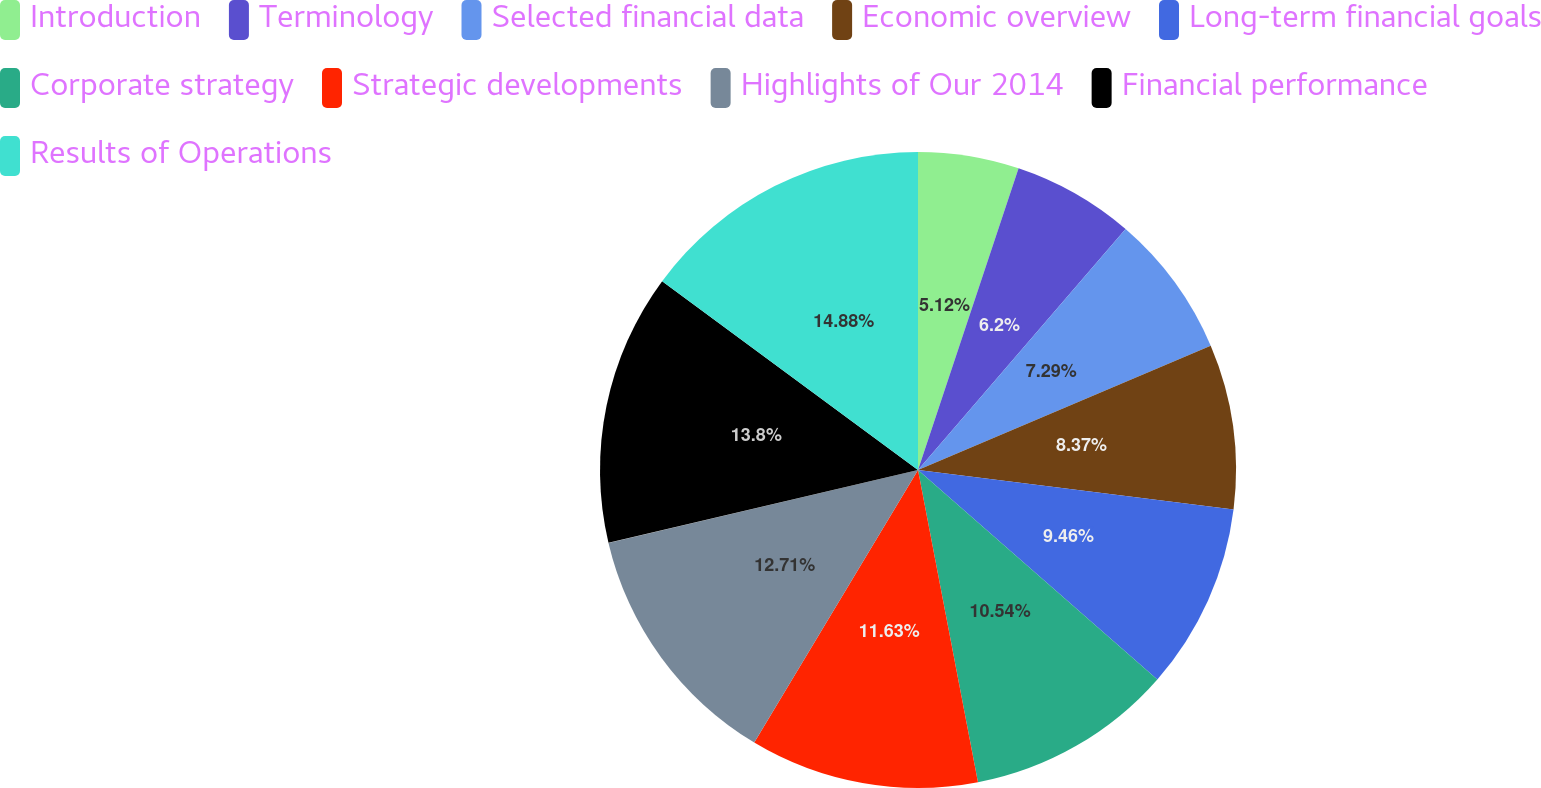Convert chart. <chart><loc_0><loc_0><loc_500><loc_500><pie_chart><fcel>Introduction<fcel>Terminology<fcel>Selected financial data<fcel>Economic overview<fcel>Long-term financial goals<fcel>Corporate strategy<fcel>Strategic developments<fcel>Highlights of Our 2014<fcel>Financial performance<fcel>Results of Operations<nl><fcel>5.12%<fcel>6.2%<fcel>7.29%<fcel>8.37%<fcel>9.46%<fcel>10.54%<fcel>11.63%<fcel>12.71%<fcel>13.8%<fcel>14.88%<nl></chart> 